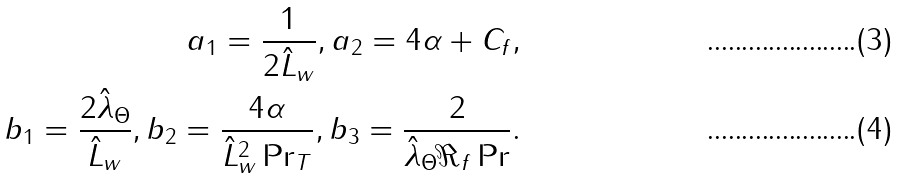Convert formula to latex. <formula><loc_0><loc_0><loc_500><loc_500>a _ { 1 } = \frac { 1 } { 2 \hat { L } _ { w } } , a _ { 2 } = 4 \alpha + C _ { f } , \\ b _ { 1 } = \frac { 2 \hat { \lambda } _ { \Theta } } { \hat { L } _ { w } } , b _ { 2 } = \frac { 4 \alpha } { \hat { L } _ { w } ^ { 2 } \Pr _ { T } } , b _ { 3 } = \frac { 2 } { \hat { \lambda } _ { \Theta } \Re _ { f } \Pr } .</formula> 